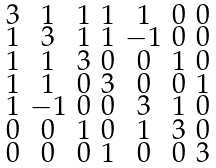Convert formula to latex. <formula><loc_0><loc_0><loc_500><loc_500>\begin{smallmatrix} 3 & 1 & 1 & 1 & 1 & 0 & 0 \\ 1 & 3 & 1 & 1 & - 1 & 0 & 0 \\ 1 & 1 & 3 & 0 & 0 & 1 & 0 \\ 1 & 1 & 0 & 3 & 0 & 0 & 1 \\ 1 & - 1 & 0 & 0 & 3 & 1 & 0 \\ 0 & 0 & 1 & 0 & 1 & 3 & 0 \\ 0 & 0 & 0 & 1 & 0 & 0 & 3 \end{smallmatrix}</formula> 